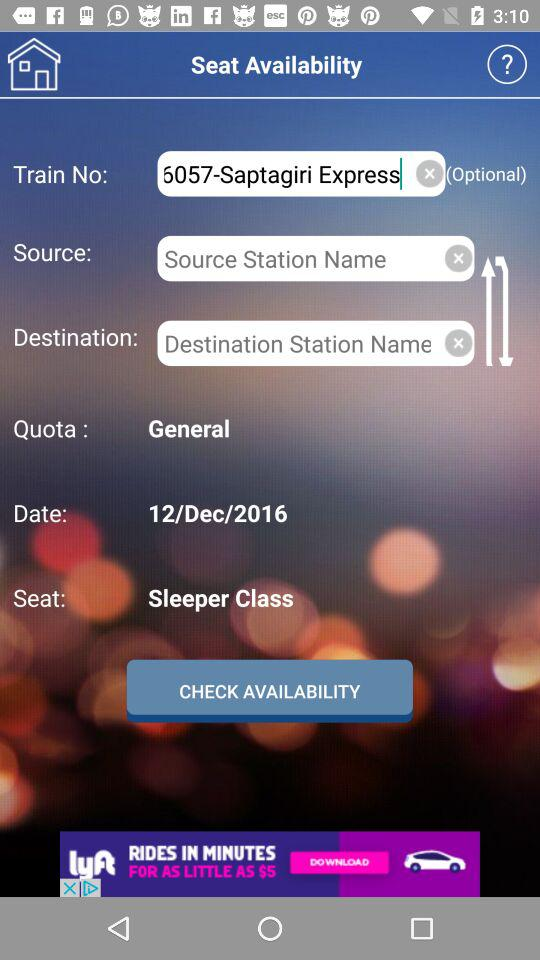Which coach is selected? The selected coach is "Sleeper Class". 